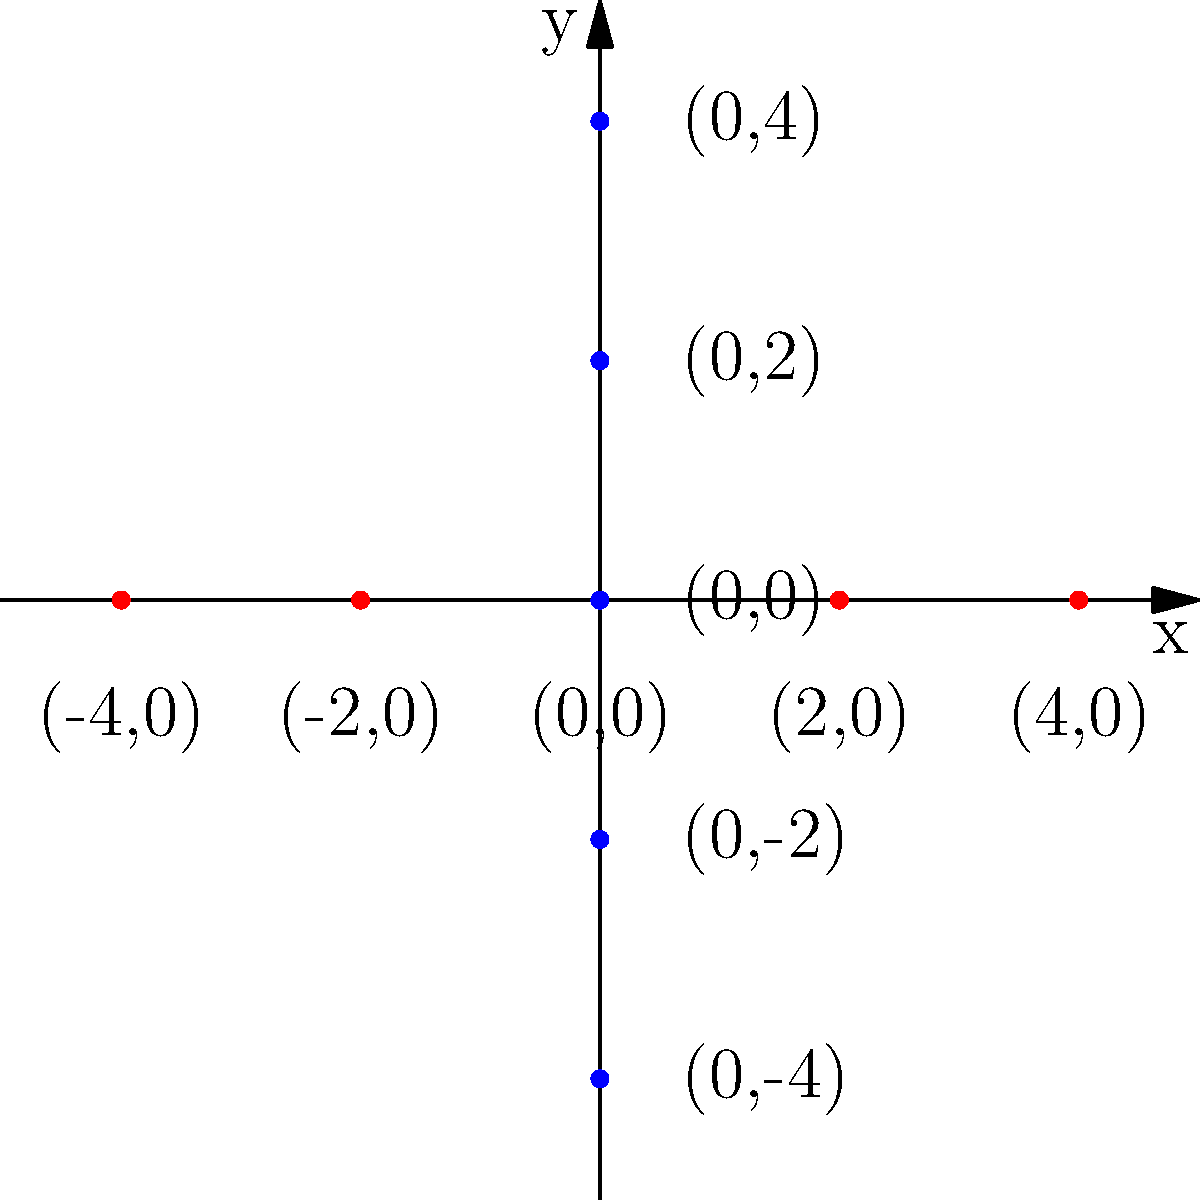On the given coordinate plane, plot the following points to create a peaceful landscape:
A $(-3, 1)$, B $(-1, 3)$, C $(1, 3)$, D $(3, 1)$, E $(-4, -1)$, F $(4, -1)$
Connect the points A, B, C, and D to form a mountain. Connect points E and F to form the ground.
What shape does the mountain resemble? Let's approach this step-by-step:

1. Plot the given points on the coordinate plane:
   A $(-3, 1)$
   B $(-1, 3)$
   C $(1, 3)$
   D $(3, 1)$
   E $(-4, -1)$
   F $(4, -1)$

2. Connect points A, B, C, and D in order. This forms the mountain shape.

3. Connect points E and F. This forms the ground line.

4. Analyze the shape formed by points A, B, C, and D:
   - It starts at point A, rises to point B
   - Remains level from B to C (forming a flat top)
   - Then descends from C to D

5. This shape resembles a trapezoid:
   - The flat top (BC) is parallel to the base (AD)
   - The sides (AB and CD) are not parallel

Therefore, the mountain in this peaceful landscape resembles a trapezoid.
Answer: Trapezoid 